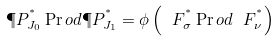Convert formula to latex. <formula><loc_0><loc_0><loc_500><loc_500>\P P ^ { ^ { * } } _ { J _ { 0 } } \Pr o d \P P ^ { ^ { * } } _ { J _ { 1 } } = \phi \left ( \ F ^ { ^ { * } } _ { \sigma } \Pr o d \ F ^ { ^ { * } } _ { \nu } \right )</formula> 